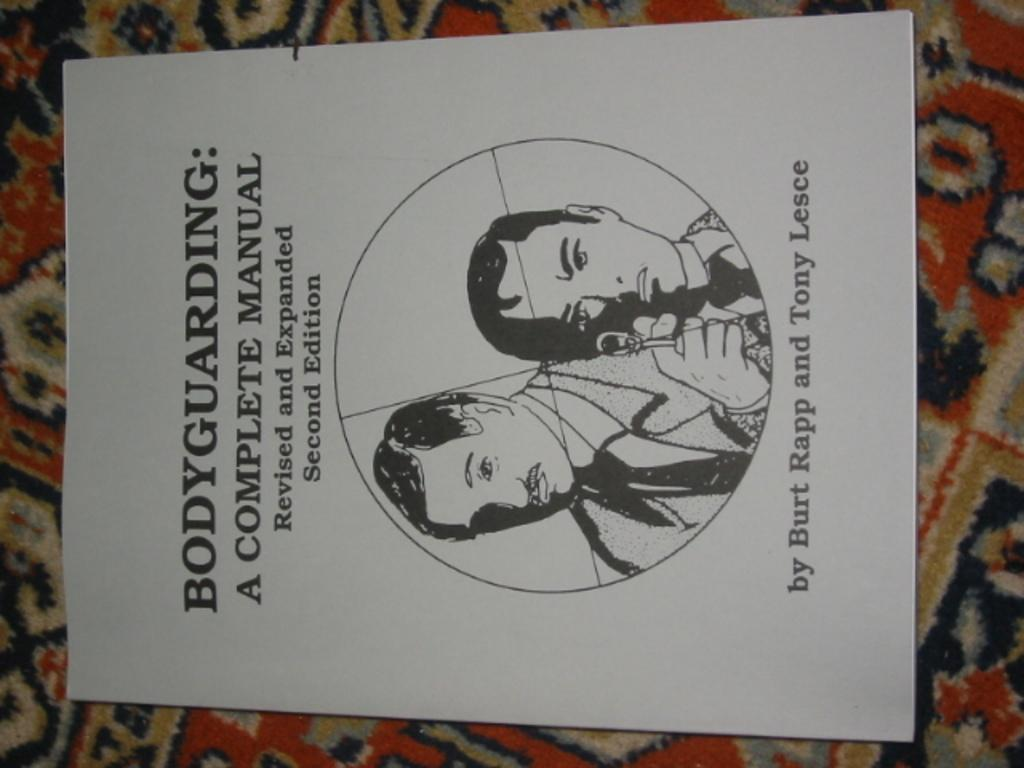<image>
Write a terse but informative summary of the picture. A body-guarding manual by Burt Rapp and Tony Lesce. 